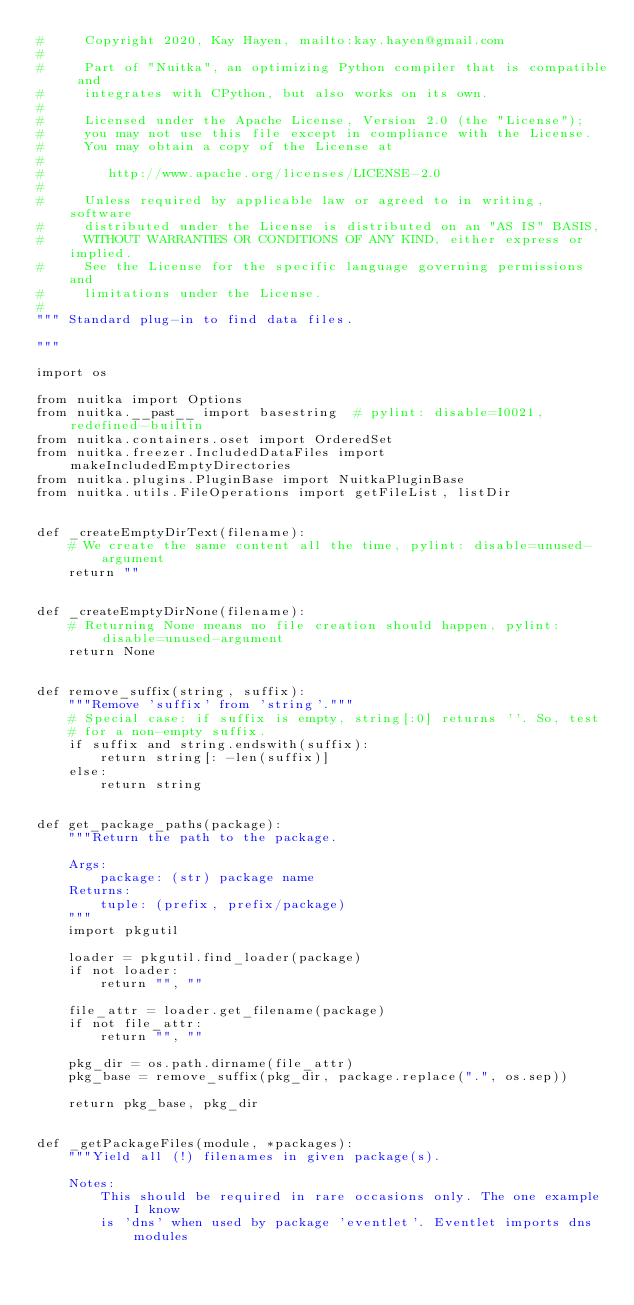Convert code to text. <code><loc_0><loc_0><loc_500><loc_500><_Python_>#     Copyright 2020, Kay Hayen, mailto:kay.hayen@gmail.com
#
#     Part of "Nuitka", an optimizing Python compiler that is compatible and
#     integrates with CPython, but also works on its own.
#
#     Licensed under the Apache License, Version 2.0 (the "License");
#     you may not use this file except in compliance with the License.
#     You may obtain a copy of the License at
#
#        http://www.apache.org/licenses/LICENSE-2.0
#
#     Unless required by applicable law or agreed to in writing, software
#     distributed under the License is distributed on an "AS IS" BASIS,
#     WITHOUT WARRANTIES OR CONDITIONS OF ANY KIND, either express or implied.
#     See the License for the specific language governing permissions and
#     limitations under the License.
#
""" Standard plug-in to find data files.

"""

import os

from nuitka import Options
from nuitka.__past__ import basestring  # pylint: disable=I0021,redefined-builtin
from nuitka.containers.oset import OrderedSet
from nuitka.freezer.IncludedDataFiles import makeIncludedEmptyDirectories
from nuitka.plugins.PluginBase import NuitkaPluginBase
from nuitka.utils.FileOperations import getFileList, listDir


def _createEmptyDirText(filename):
    # We create the same content all the time, pylint: disable=unused-argument
    return ""


def _createEmptyDirNone(filename):
    # Returning None means no file creation should happen, pylint: disable=unused-argument
    return None


def remove_suffix(string, suffix):
    """Remove 'suffix' from 'string'."""
    # Special case: if suffix is empty, string[:0] returns ''. So, test
    # for a non-empty suffix.
    if suffix and string.endswith(suffix):
        return string[: -len(suffix)]
    else:
        return string


def get_package_paths(package):
    """Return the path to the package.

    Args:
        package: (str) package name
    Returns:
        tuple: (prefix, prefix/package)
    """
    import pkgutil

    loader = pkgutil.find_loader(package)
    if not loader:
        return "", ""

    file_attr = loader.get_filename(package)
    if not file_attr:
        return "", ""

    pkg_dir = os.path.dirname(file_attr)
    pkg_base = remove_suffix(pkg_dir, package.replace(".", os.sep))

    return pkg_base, pkg_dir


def _getPackageFiles(module, *packages):
    """Yield all (!) filenames in given package(s).

    Notes:
        This should be required in rare occasions only. The one example I know
        is 'dns' when used by package 'eventlet'. Eventlet imports dns modules</code> 